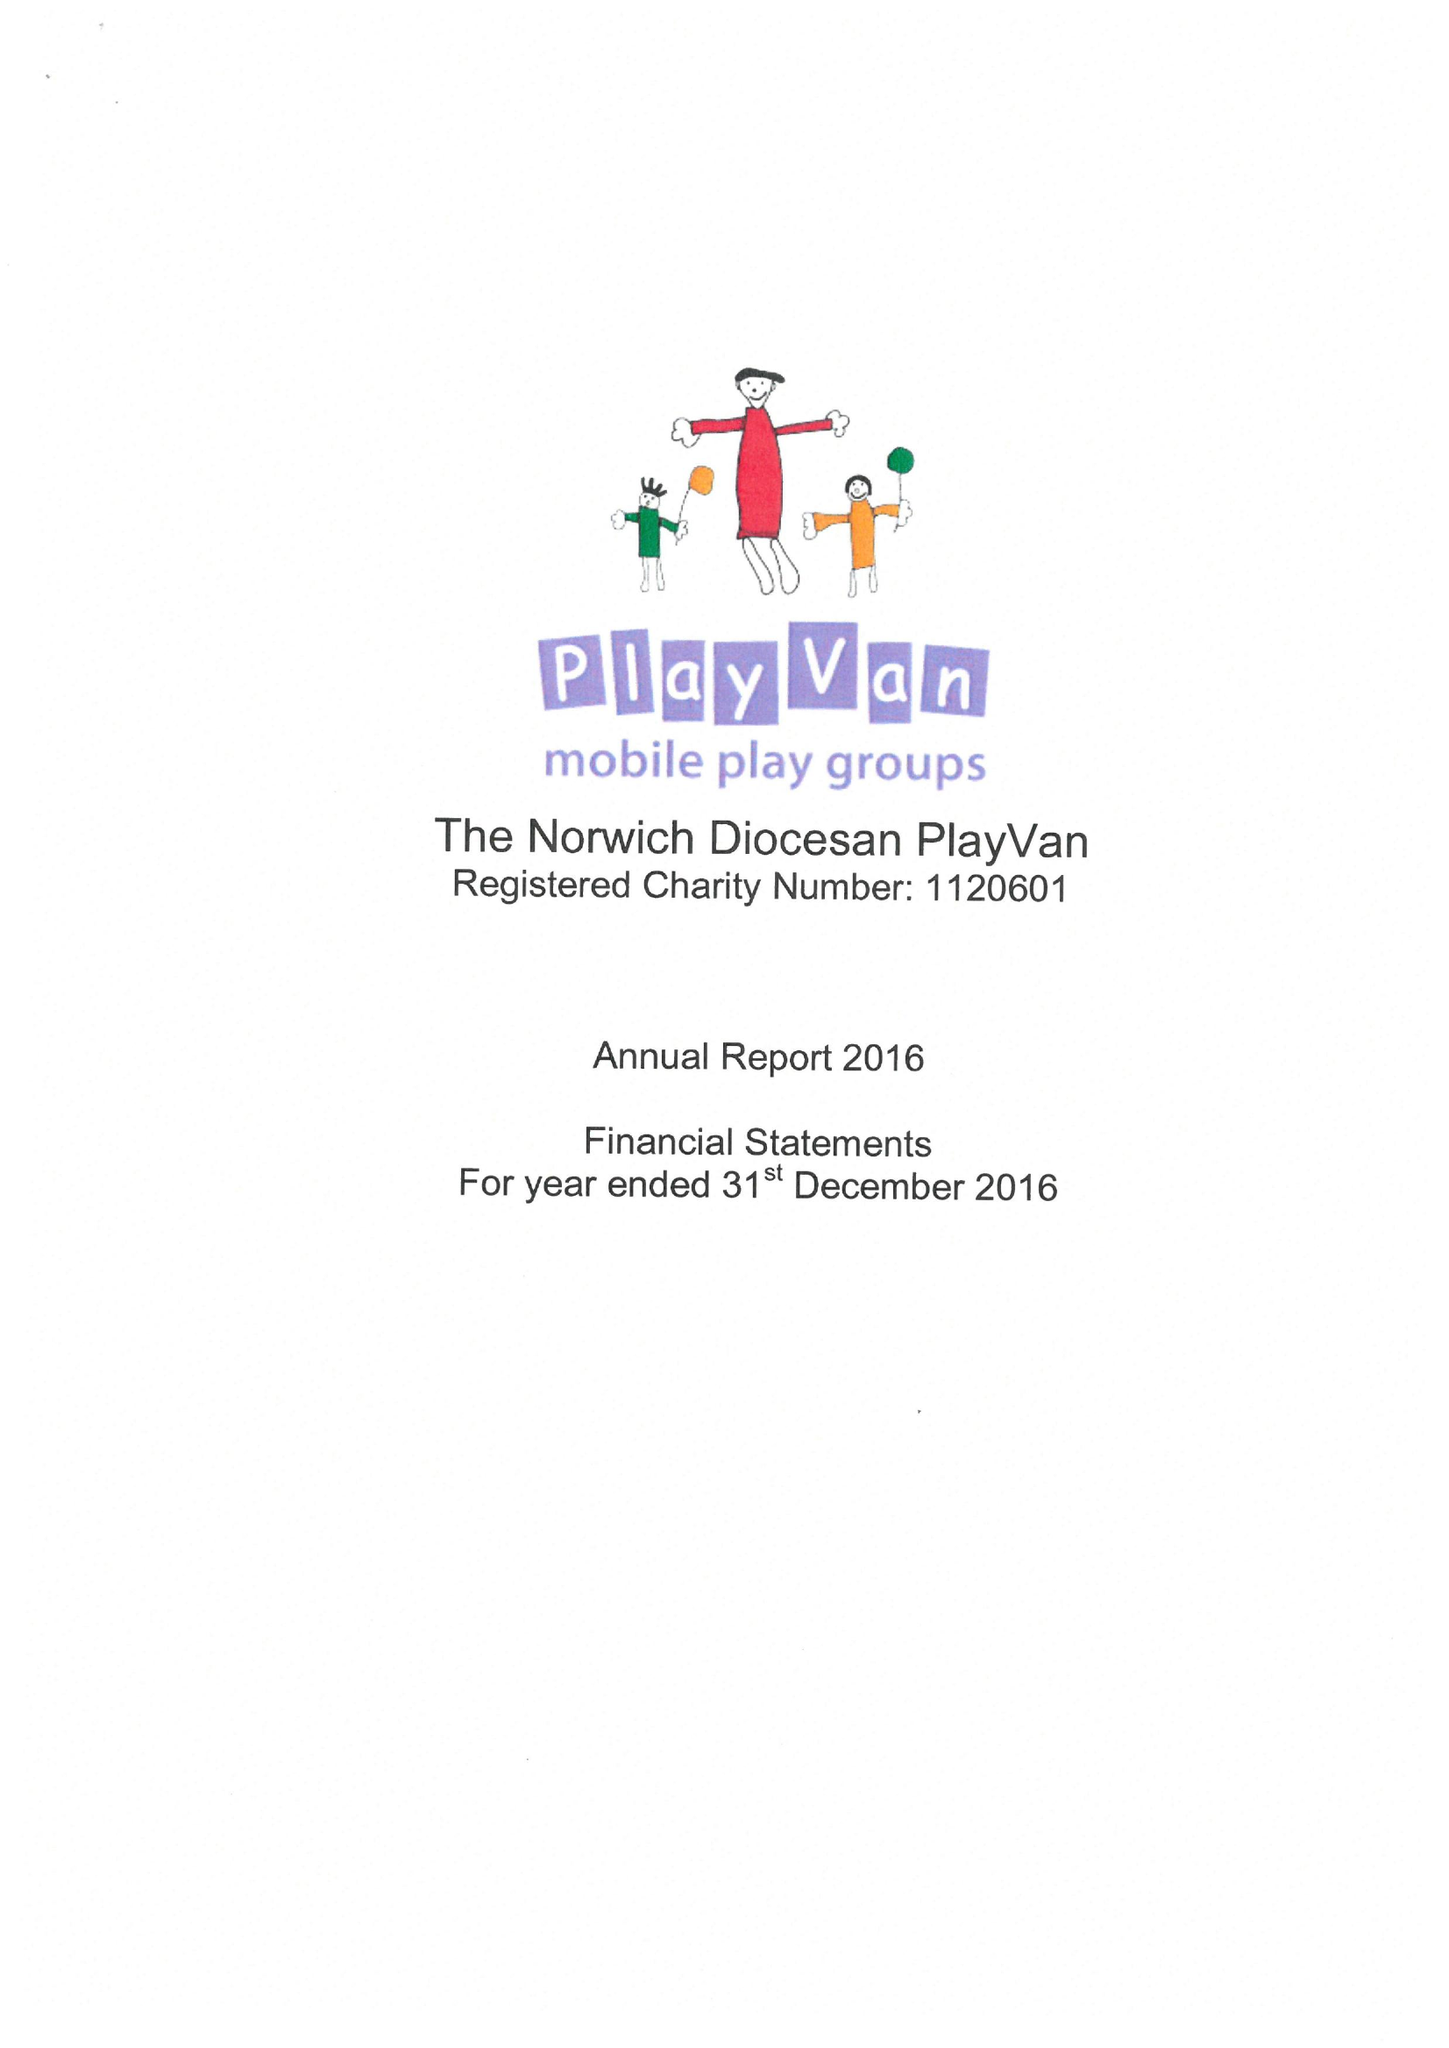What is the value for the charity_number?
Answer the question using a single word or phrase. 1120601 